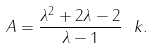Convert formula to latex. <formula><loc_0><loc_0><loc_500><loc_500>A = \frac { \lambda ^ { 2 } + 2 \lambda - 2 } { \lambda - 1 } \ k .</formula> 